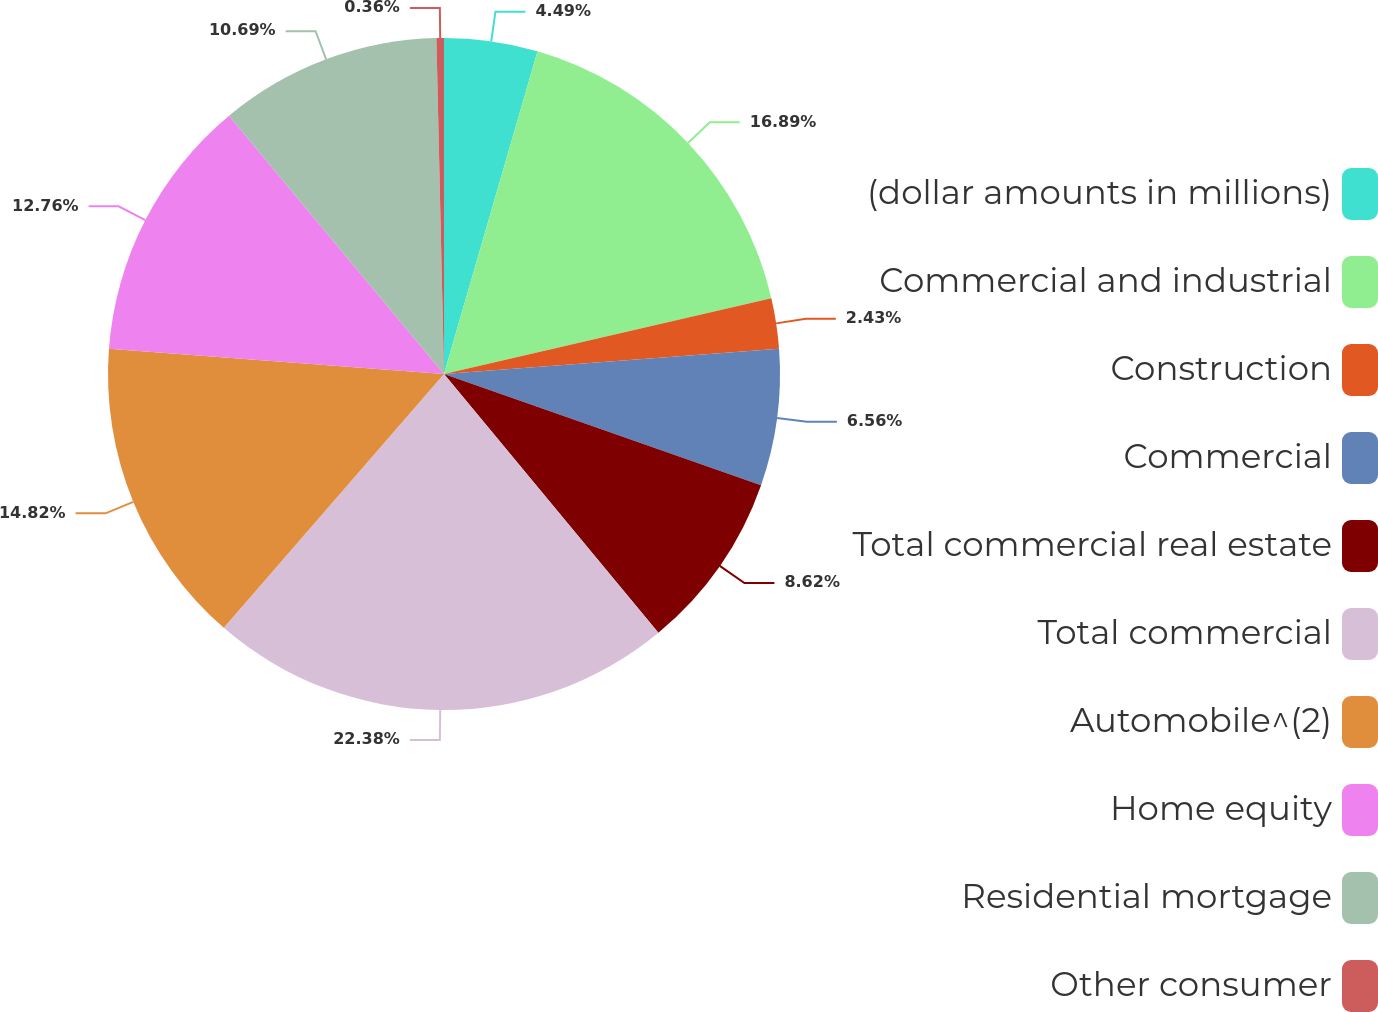Convert chart to OTSL. <chart><loc_0><loc_0><loc_500><loc_500><pie_chart><fcel>(dollar amounts in millions)<fcel>Commercial and industrial<fcel>Construction<fcel>Commercial<fcel>Total commercial real estate<fcel>Total commercial<fcel>Automobile^(2)<fcel>Home equity<fcel>Residential mortgage<fcel>Other consumer<nl><fcel>4.49%<fcel>16.89%<fcel>2.43%<fcel>6.56%<fcel>8.62%<fcel>22.39%<fcel>14.82%<fcel>12.76%<fcel>10.69%<fcel>0.36%<nl></chart> 